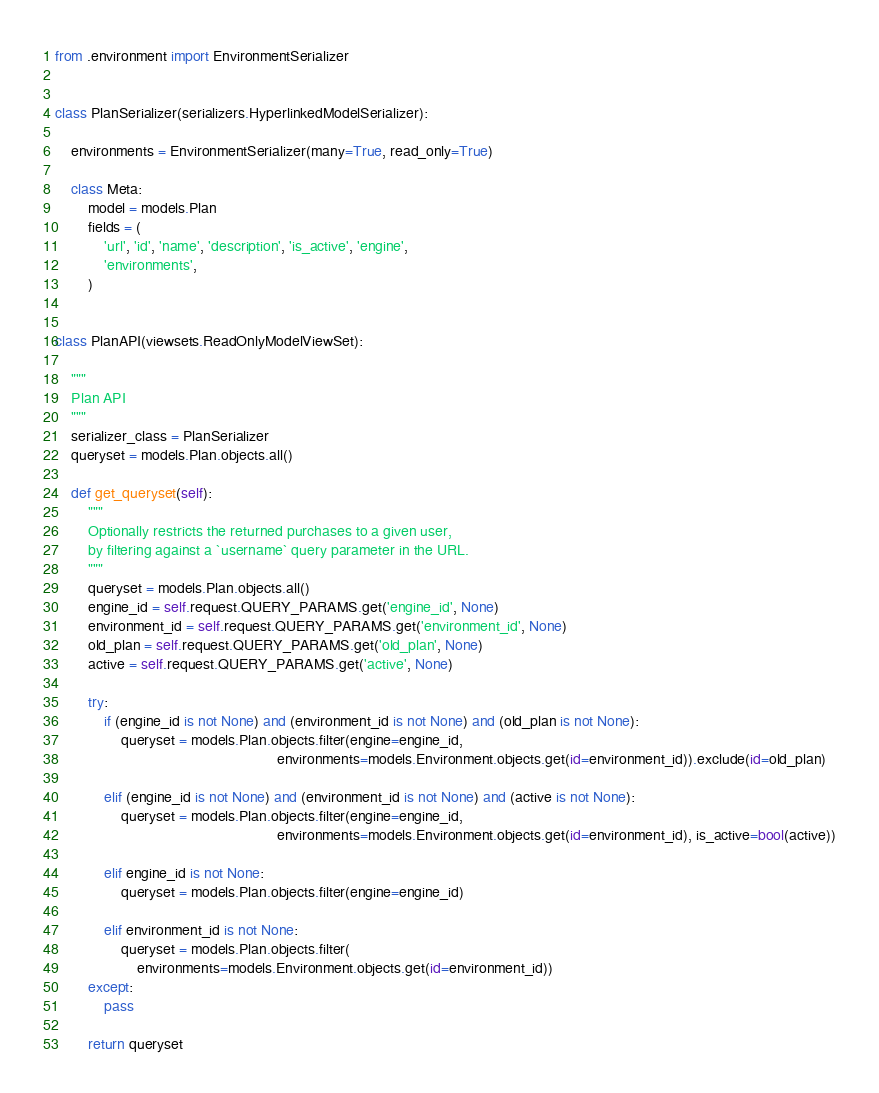<code> <loc_0><loc_0><loc_500><loc_500><_Python_>from .environment import EnvironmentSerializer


class PlanSerializer(serializers.HyperlinkedModelSerializer):

    environments = EnvironmentSerializer(many=True, read_only=True)

    class Meta:
        model = models.Plan
        fields = (
            'url', 'id', 'name', 'description', 'is_active', 'engine',
            'environments',
        )


class PlanAPI(viewsets.ReadOnlyModelViewSet):

    """
    Plan API
    """
    serializer_class = PlanSerializer
    queryset = models.Plan.objects.all()

    def get_queryset(self):
        """
        Optionally restricts the returned purchases to a given user,
        by filtering against a `username` query parameter in the URL.
        """
        queryset = models.Plan.objects.all()
        engine_id = self.request.QUERY_PARAMS.get('engine_id', None)
        environment_id = self.request.QUERY_PARAMS.get('environment_id', None)
        old_plan = self.request.QUERY_PARAMS.get('old_plan', None)
        active = self.request.QUERY_PARAMS.get('active', None)

        try:
            if (engine_id is not None) and (environment_id is not None) and (old_plan is not None):
                queryset = models.Plan.objects.filter(engine=engine_id,
                                                      environments=models.Environment.objects.get(id=environment_id)).exclude(id=old_plan)

            elif (engine_id is not None) and (environment_id is not None) and (active is not None):
                queryset = models.Plan.objects.filter(engine=engine_id,
                                                      environments=models.Environment.objects.get(id=environment_id), is_active=bool(active))

            elif engine_id is not None:
                queryset = models.Plan.objects.filter(engine=engine_id)

            elif environment_id is not None:
                queryset = models.Plan.objects.filter(
                    environments=models.Environment.objects.get(id=environment_id))
        except:
            pass

        return queryset
</code> 